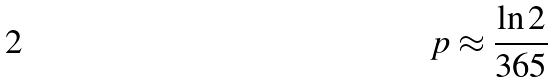<formula> <loc_0><loc_0><loc_500><loc_500>p \approx \frac { \ln 2 } { 3 6 5 }</formula> 